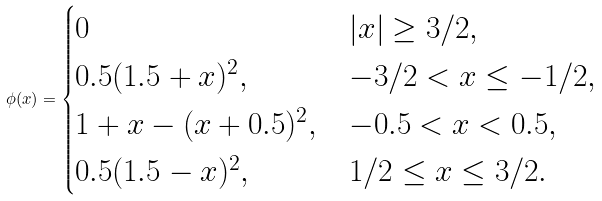Convert formula to latex. <formula><loc_0><loc_0><loc_500><loc_500>\phi ( x ) = \begin{cases} 0 & | x | \geq 3 / 2 , \\ 0 . 5 ( 1 . 5 + x ) ^ { 2 } , & - 3 / 2 < x \leq - 1 / 2 , \\ 1 + x - ( x + 0 . 5 ) ^ { 2 } , & - 0 . 5 < x < 0 . 5 , \\ 0 . 5 ( 1 . 5 - x ) ^ { 2 } , & 1 / 2 \leq x \leq 3 / 2 . \end{cases}</formula> 